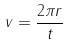Convert formula to latex. <formula><loc_0><loc_0><loc_500><loc_500>v = \frac { 2 \pi r } { t }</formula> 